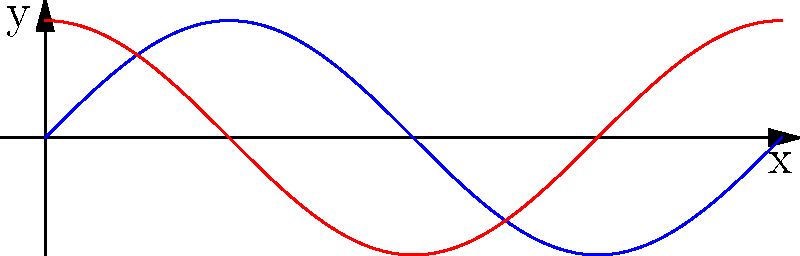In a classic rock concert, two guitarists are playing the same note, but their sound waves are slightly out of phase. The diagram shows two sinusoidal waves representing their guitar sounds. If Wave 1 is represented by $y_1 = \sin(x)$ and Wave 2 is represented by $y_2 = \sin(x + \phi)$, where $\phi$ is the phase shift, determine the value of $\phi$ in radians. To find the phase shift between the two waves, we can follow these steps:

1) Wave 1 is represented by $y_1 = \sin(x)$, which is our reference wave.

2) Wave 2 is represented by $y_2 = \sin(x + \phi)$, where $\phi$ is the phase shift we need to find.

3) From the graph, we can see that Wave 2 (red) appears to reach its maximum earlier than Wave 1 (blue).

4) The phase shift between sine waves can be determined by how much earlier or later one wave reaches its peak compared to the other.

5) In this case, Wave 2 reaches its peak $\frac{\pi}{2}$ radians (or 90°) before Wave 1.

6) Therefore, to shift Wave 1 to match Wave 2, we need to add $\frac{\pi}{2}$ to the argument of the sine function.

7) This means $\phi = \frac{\pi}{2}$ radians.

8) We can verify this by substituting into the equation for Wave 2:
   $y_2 = \sin(x + \frac{\pi}{2})$

This matches the graph, confirming our answer.
Answer: $\frac{\pi}{2}$ radians 